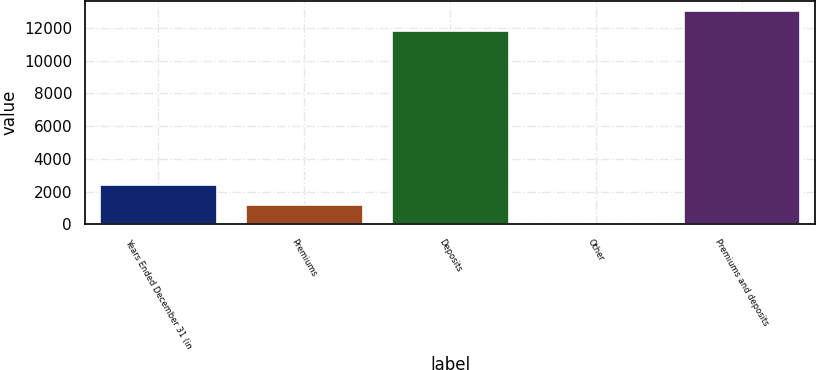<chart> <loc_0><loc_0><loc_500><loc_500><bar_chart><fcel>Years Ended December 31 (in<fcel>Premiums<fcel>Deposits<fcel>Other<fcel>Premiums and deposits<nl><fcel>2384.4<fcel>1194.2<fcel>11819<fcel>4<fcel>13009.2<nl></chart> 